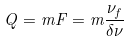<formula> <loc_0><loc_0><loc_500><loc_500>Q = m F = m \frac { \nu _ { f } } { \delta \nu }</formula> 